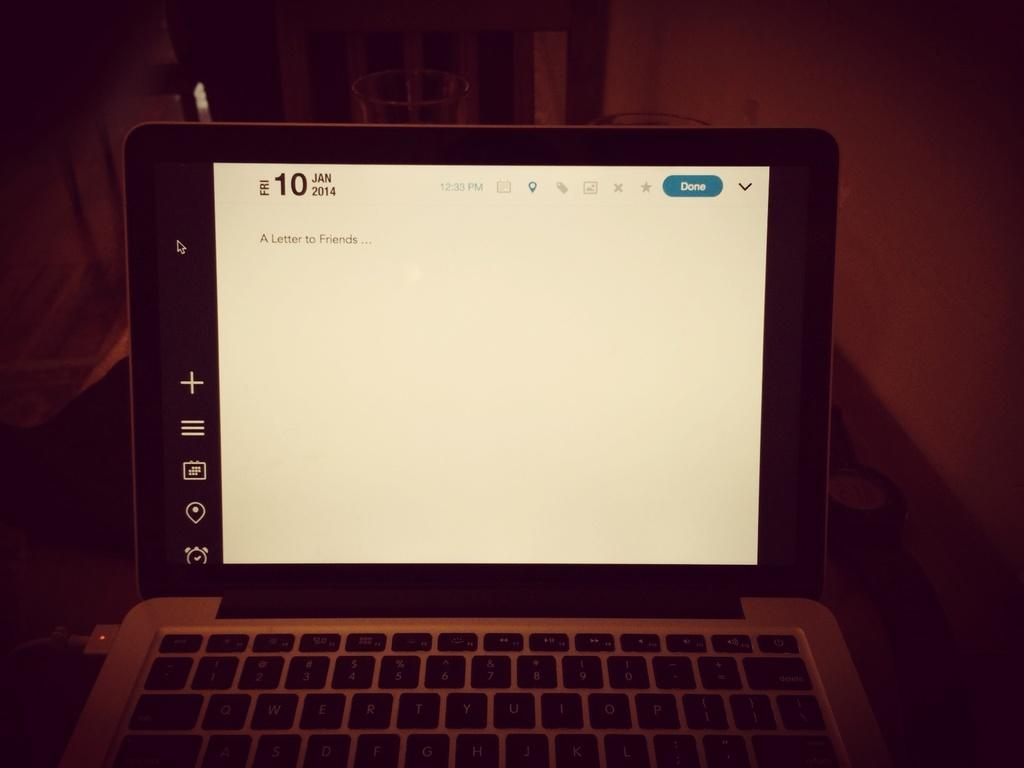<image>
Provide a brief description of the given image. A laptop is plugged in and the screen says January 10. 